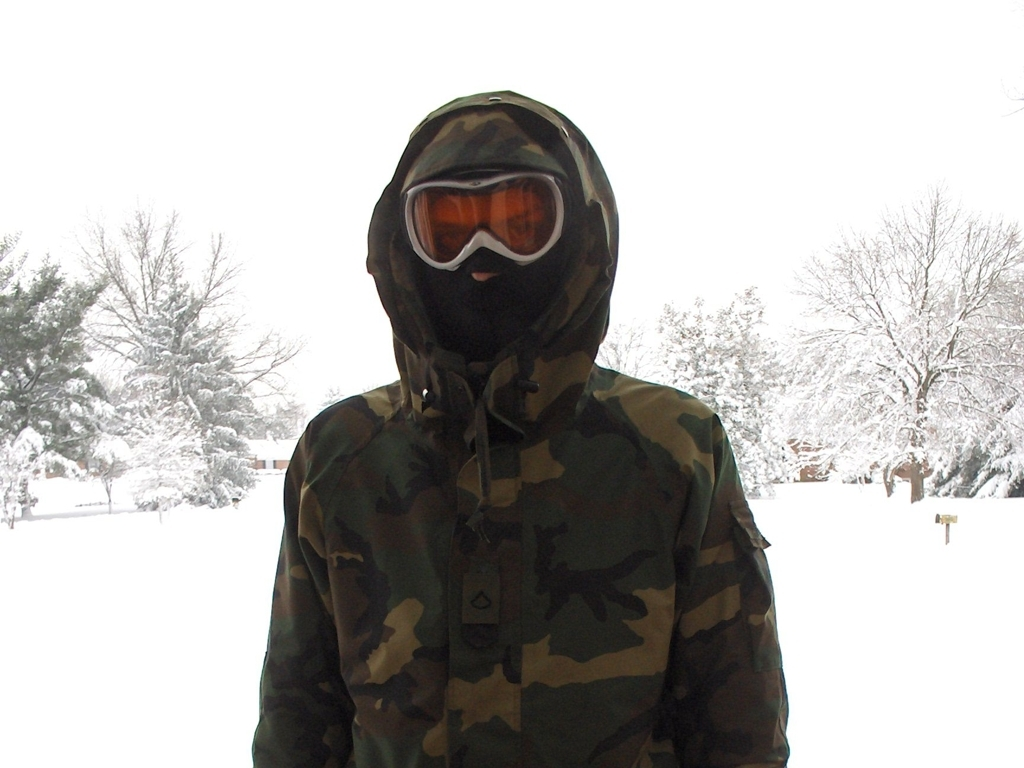What kind of clothing is the person in the image wearing and why might they have chosen this outfit? The person is wearing a camouflage winter coat with a hood and ski goggles. Given the snowy backdrop, it's likely they chose this outfit to stay warm and perhaps to blend in with the winter environment for activities such as hunting or winter sports. 